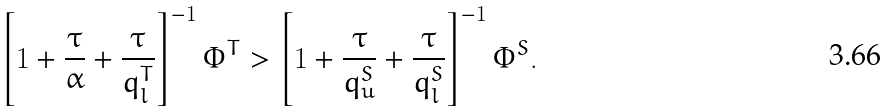Convert formula to latex. <formula><loc_0><loc_0><loc_500><loc_500>\left [ 1 + \frac { \tau } { \alpha } + \frac { \tau } { q _ { l } ^ { T } } \right ] ^ { - 1 } \Phi ^ { T } > \left [ 1 + \frac { \tau } { q _ { u } ^ { S } } + \frac { \tau } { q _ { l } ^ { S } } \right ] ^ { - 1 } \Phi ^ { S } .</formula> 